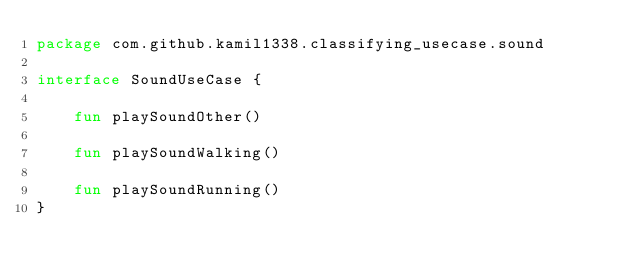<code> <loc_0><loc_0><loc_500><loc_500><_Kotlin_>package com.github.kamil1338.classifying_usecase.sound

interface SoundUseCase {

    fun playSoundOther()

    fun playSoundWalking()

    fun playSoundRunning()
}</code> 